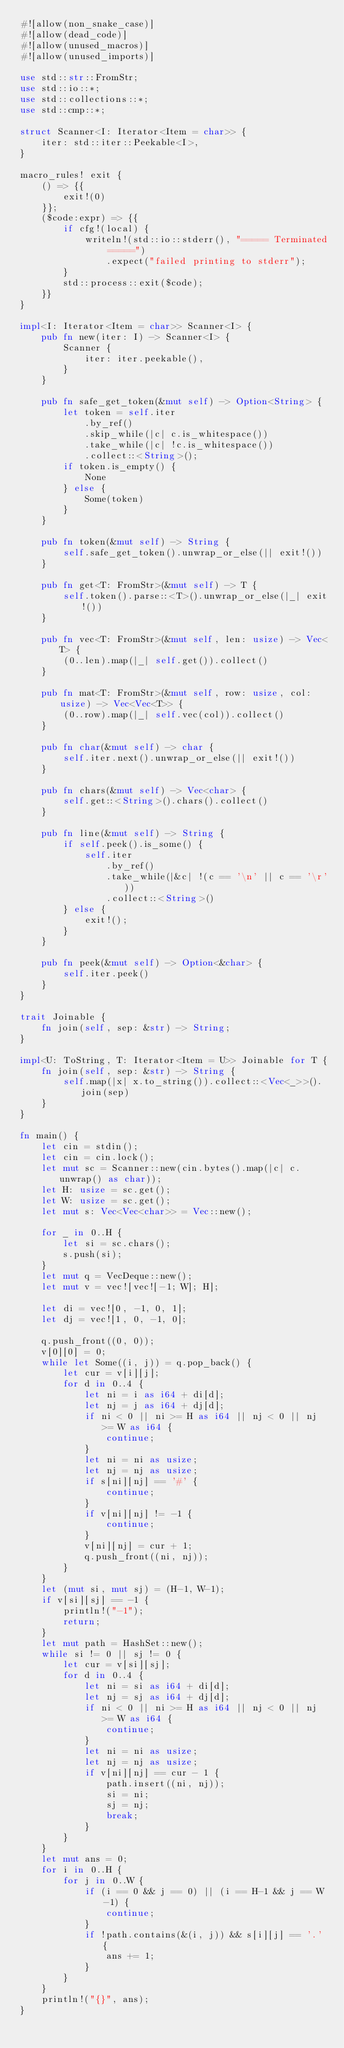Convert code to text. <code><loc_0><loc_0><loc_500><loc_500><_Rust_>#![allow(non_snake_case)]
#![allow(dead_code)]
#![allow(unused_macros)]
#![allow(unused_imports)]

use std::str::FromStr;
use std::io::*;
use std::collections::*;
use std::cmp::*;

struct Scanner<I: Iterator<Item = char>> {
    iter: std::iter::Peekable<I>,
}

macro_rules! exit {
    () => {{
        exit!(0)
    }};
    ($code:expr) => {{
        if cfg!(local) {
            writeln!(std::io::stderr(), "===== Terminated =====")
                .expect("failed printing to stderr");
        }
        std::process::exit($code);
    }}
}

impl<I: Iterator<Item = char>> Scanner<I> {
    pub fn new(iter: I) -> Scanner<I> {
        Scanner {
            iter: iter.peekable(),
        }
    }

    pub fn safe_get_token(&mut self) -> Option<String> {
        let token = self.iter
            .by_ref()
            .skip_while(|c| c.is_whitespace())
            .take_while(|c| !c.is_whitespace())
            .collect::<String>();
        if token.is_empty() {
            None
        } else {
            Some(token)
        }
    }

    pub fn token(&mut self) -> String {
        self.safe_get_token().unwrap_or_else(|| exit!())
    }

    pub fn get<T: FromStr>(&mut self) -> T {
        self.token().parse::<T>().unwrap_or_else(|_| exit!())
    }

    pub fn vec<T: FromStr>(&mut self, len: usize) -> Vec<T> {
        (0..len).map(|_| self.get()).collect()
    }

    pub fn mat<T: FromStr>(&mut self, row: usize, col: usize) -> Vec<Vec<T>> {
        (0..row).map(|_| self.vec(col)).collect()
    }

    pub fn char(&mut self) -> char {
        self.iter.next().unwrap_or_else(|| exit!())
    }

    pub fn chars(&mut self) -> Vec<char> {
        self.get::<String>().chars().collect()
    }

    pub fn line(&mut self) -> String {
        if self.peek().is_some() {
            self.iter
                .by_ref()
                .take_while(|&c| !(c == '\n' || c == '\r'))
                .collect::<String>()
        } else {
            exit!();
        }
    }

    pub fn peek(&mut self) -> Option<&char> {
        self.iter.peek()
    }
}

trait Joinable {
    fn join(self, sep: &str) -> String;
}

impl<U: ToString, T: Iterator<Item = U>> Joinable for T {
    fn join(self, sep: &str) -> String {
        self.map(|x| x.to_string()).collect::<Vec<_>>().join(sep)
    }
}

fn main() {
    let cin = stdin();
    let cin = cin.lock();
    let mut sc = Scanner::new(cin.bytes().map(|c| c.unwrap() as char));
    let H: usize = sc.get();
    let W: usize = sc.get();
    let mut s: Vec<Vec<char>> = Vec::new();

    for _ in 0..H {
        let si = sc.chars();
        s.push(si);
    }
    let mut q = VecDeque::new();
    let mut v = vec![vec![-1; W]; H];

    let di = vec![0, -1, 0, 1];
    let dj = vec![1, 0, -1, 0];

    q.push_front((0, 0));
    v[0][0] = 0;
    while let Some((i, j)) = q.pop_back() {
        let cur = v[i][j];
        for d in 0..4 {
            let ni = i as i64 + di[d];
            let nj = j as i64 + dj[d];
            if ni < 0 || ni >= H as i64 || nj < 0 || nj >= W as i64 {
                continue;
            }
            let ni = ni as usize;
            let nj = nj as usize;
            if s[ni][nj] == '#' {
                continue;
            }
            if v[ni][nj] != -1 {
                continue;
            }
            v[ni][nj] = cur + 1;
            q.push_front((ni, nj));
        }
    }
    let (mut si, mut sj) = (H-1, W-1);
    if v[si][sj] == -1 {
        println!("-1");
        return;
    }
    let mut path = HashSet::new();
    while si != 0 || sj != 0 {
        let cur = v[si][sj];
        for d in 0..4 {
            let ni = si as i64 + di[d];
            let nj = sj as i64 + dj[d];
            if ni < 0 || ni >= H as i64 || nj < 0 || nj >= W as i64 {
                continue;
            }
            let ni = ni as usize;
            let nj = nj as usize;
            if v[ni][nj] == cur - 1 {
                path.insert((ni, nj));
                si = ni;
                sj = nj;
                break;
            }
        }
    }
    let mut ans = 0;
    for i in 0..H {
        for j in 0..W {
            if (i == 0 && j == 0) || (i == H-1 && j == W-1) {
                continue;
            }
            if !path.contains(&(i, j)) && s[i][j] == '.' {
                ans += 1;
            }
        }
    }
    println!("{}", ans);
}
</code> 